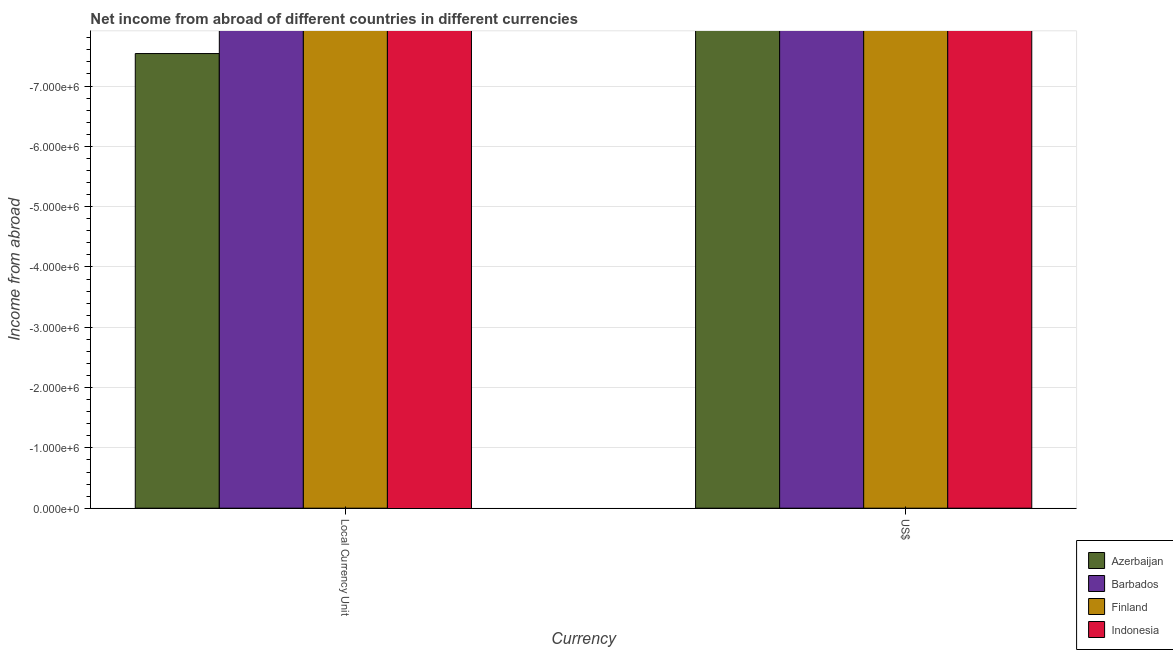Are the number of bars per tick equal to the number of legend labels?
Provide a succinct answer. No. How many bars are there on the 1st tick from the left?
Provide a short and direct response. 0. How many bars are there on the 1st tick from the right?
Give a very brief answer. 0. What is the label of the 1st group of bars from the left?
Offer a very short reply. Local Currency Unit. What is the income from abroad in us$ in Azerbaijan?
Offer a very short reply. 0. Across all countries, what is the minimum income from abroad in us$?
Give a very brief answer. 0. What is the total income from abroad in constant 2005 us$ in the graph?
Provide a short and direct response. 0. What is the difference between the income from abroad in constant 2005 us$ in Finland and the income from abroad in us$ in Barbados?
Give a very brief answer. 0. What is the average income from abroad in constant 2005 us$ per country?
Keep it short and to the point. 0. How many bars are there?
Your answer should be compact. 0. Are all the bars in the graph horizontal?
Your answer should be compact. No. Where does the legend appear in the graph?
Provide a succinct answer. Bottom right. What is the title of the graph?
Make the answer very short. Net income from abroad of different countries in different currencies. What is the label or title of the X-axis?
Offer a very short reply. Currency. What is the label or title of the Y-axis?
Provide a short and direct response. Income from abroad. What is the Income from abroad of Azerbaijan in US$?
Provide a succinct answer. 0. What is the Income from abroad of Finland in US$?
Make the answer very short. 0. What is the total Income from abroad in Indonesia in the graph?
Ensure brevity in your answer.  0. What is the average Income from abroad in Azerbaijan per Currency?
Provide a succinct answer. 0. What is the average Income from abroad in Barbados per Currency?
Provide a succinct answer. 0. What is the average Income from abroad in Finland per Currency?
Your response must be concise. 0. 